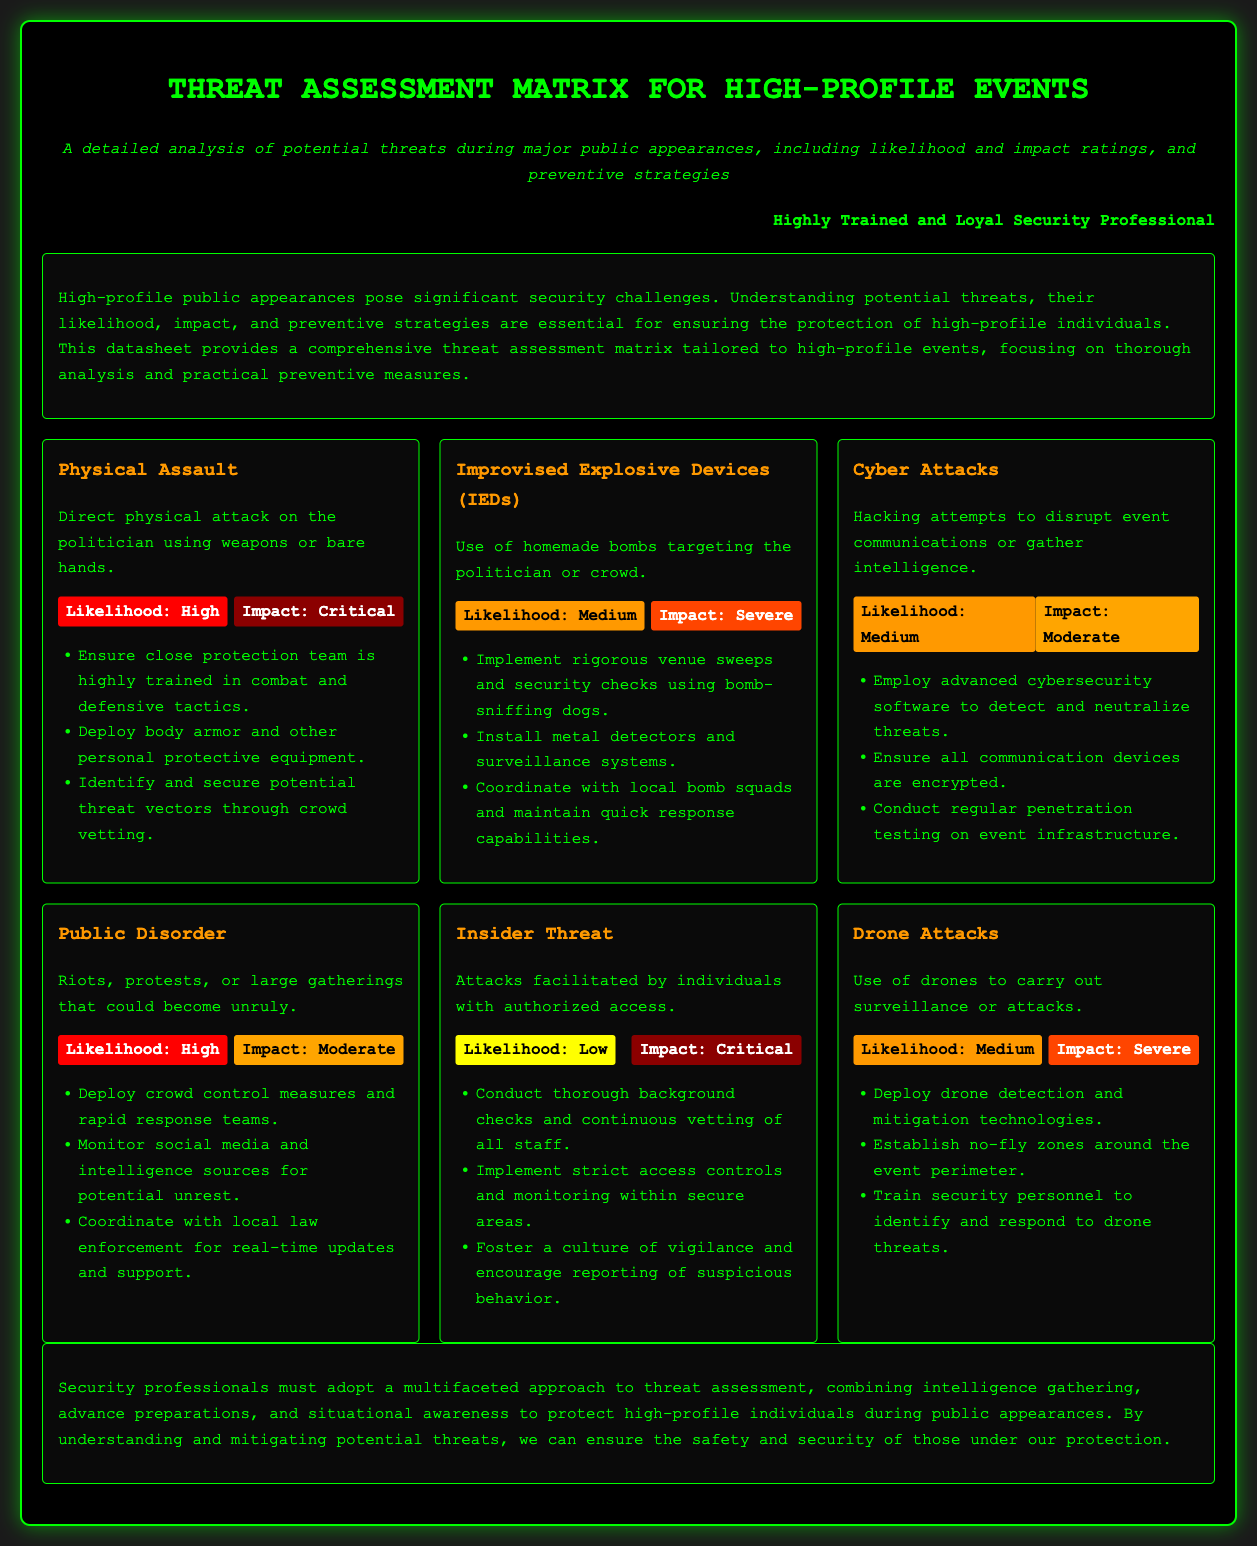What is the title of the document? The title is prominently displayed at the top of the document.
Answer: Threat Assessment Matrix for High-Profile Events What is the likelihood rating for Physical Assault? The document lists the likelihood rating next to each threat description.
Answer: High What is the impact rating for Cyber Attacks? The impact rating is shown as part of the threat's details in the document.
Answer: Moderate What preventive strategy is recommended for Drone Attacks? Preventive strategies are listed under each threat.
Answer: Deploy drone detection and mitigation technologies Which threat has a low likelihood rating? The likelihood ratings are clearly indicated for each threat in the matrix.
Answer: Insider Threat What is the likelihood of Public Disorder? The likelihood is stated in the matrix section for that specific threat.
Answer: High What impact rating is given to Improvised Explosive Devices? The impact rating can be found in the description of that threat.
Answer: Severe What type of individual poses an Insider Threat? The document explains what kind of individuals are categorized under each threat.
Answer: Individuals with authorized access What should be deployed to mitigate risks associated with IEDs? Specific preventive measures are recommended to address each threat.
Answer: Bomb-sniffing dogs 